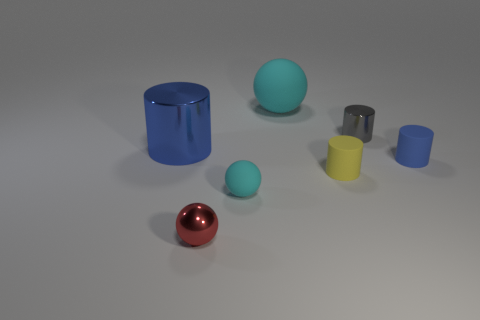Does the big rubber ball have the same color as the tiny metal sphere?
Offer a very short reply. No. What number of other objects are the same material as the gray cylinder?
Ensure brevity in your answer.  2. The small metal thing in front of the small cylinder that is to the left of the gray object is what shape?
Give a very brief answer. Sphere. What is the size of the metal cylinder in front of the gray cylinder?
Your answer should be very brief. Large. Are the gray cylinder and the yellow thing made of the same material?
Provide a succinct answer. No. There is a blue thing that is made of the same material as the tiny gray cylinder; what is its shape?
Ensure brevity in your answer.  Cylinder. Is there any other thing that is the same color as the big cylinder?
Your answer should be compact. Yes. What color is the large thing that is left of the big cyan thing?
Ensure brevity in your answer.  Blue. Does the matte thing on the right side of the small yellow rubber cylinder have the same color as the big shiny thing?
Your answer should be compact. Yes. What is the material of the large blue object that is the same shape as the tiny gray object?
Your answer should be compact. Metal. 